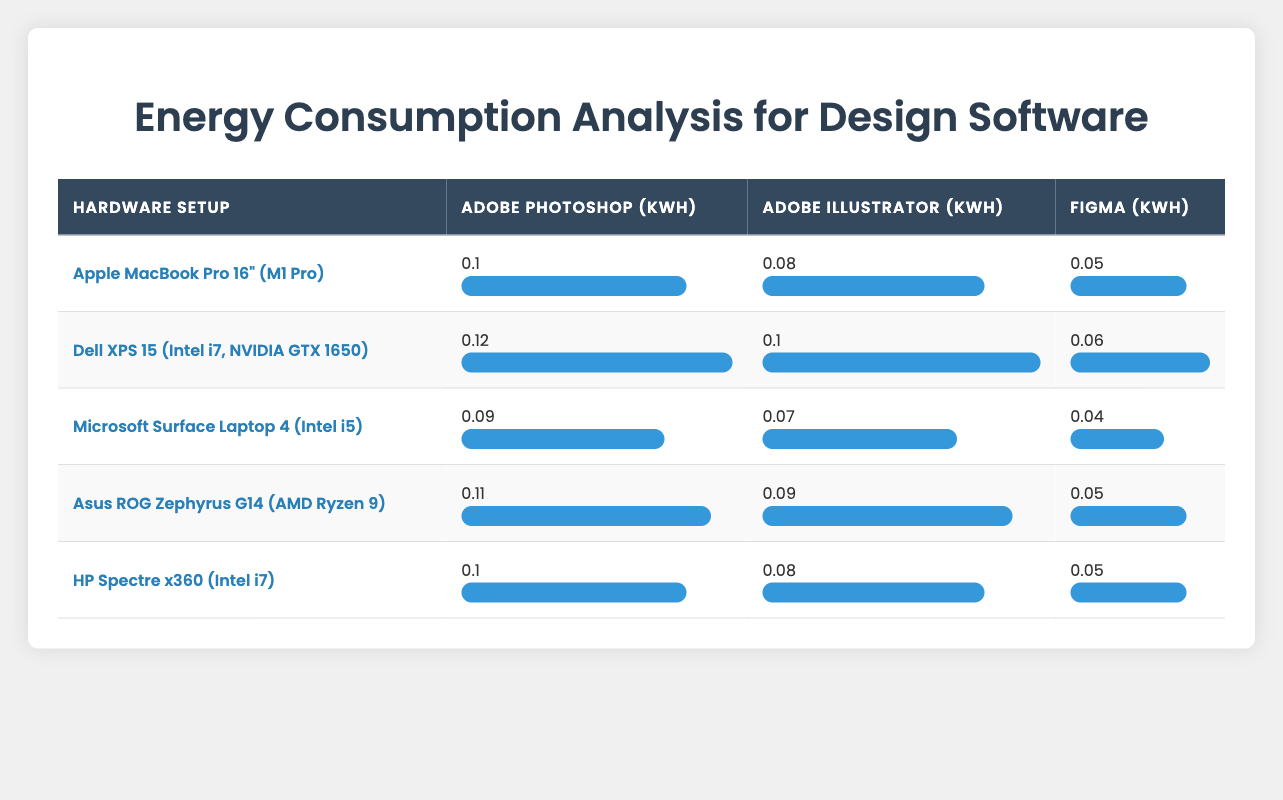What's the energy consumption of Adobe Illustrator on the Apple MacBook Pro 16"? The energy consumption for Adobe Illustrator on the Apple MacBook Pro 16" is listed as 0.08 kWh in the table.
Answer: 0.08 kWh Which hardware setup consumes the most energy running Adobe Photoshop? The table shows that the Dell XPS 15 consumes 0.12 kWh running Adobe Photoshop, which is the highest value among all setups for that software.
Answer: Dell XPS 15 What is the average energy consumption for Figma across all hardware setups? To find the average for Figma: (0.05 + 0.06 + 0.04 + 0.05 + 0.05) / 5 = 0.05 kWh. Therefore, the average Figma consumption is 0.05 kWh.
Answer: 0.05 kWh Is the energy consumption of Adobe Illustrator on the Microsoft Surface Laptop 4 greater than that on the Asus ROG Zephyrus G14? The values are 0.07 kWh for Microsoft Surface Laptop 4 and 0.09 kWh for Asus ROG Zephyrus G14. Since 0.07 is less than 0.09, the statement is false.
Answer: No How much more energy does the Dell XPS 15 consume for Adobe Photoshop compared to the Apple MacBook Pro 16"? The difference in energy consumption is 0.12 kWh (Dell XPS 15) - 0.1 kWh (Apple MacBook Pro) = 0.02 kWh. So, it consumes 0.02 kWh more.
Answer: 0.02 kWh Which setup has the least energy consumption for Adobe Illustrator, and what is that value? The lowest value for Adobe Illustrator is 0.07 kWh from the Microsoft Surface Laptop 4. This is the least value compared to others.
Answer: Microsoft Surface Laptop 4, 0.07 kWh Can you list all the setups that consume more than 0.1 kWh running Adobe Photoshop? The setups consuming more than 0.1 kWh for Adobe Photoshop are Dell XPS 15 (0.12 kWh) and Asus ROG Zephyrus G14 (0.11 kWh).
Answer: Dell XPS 15, Asus ROG Zephyrus G14 What is the total energy consumption for all setups running Figma? Adding up the energy consumption for Figma gives: 0.05 + 0.06 + 0.04 + 0.05 + 0.05 = 0.25 kWh. Therefore, the total energy consumption for Figma is 0.25 kWh.
Answer: 0.25 kWh Which hardware setup has the same energy consumption for Figma as the Apple MacBook Pro 16"? Both the Apple MacBook Pro 16" and the HP Spectre x360 have the same energy consumption for Figma at 0.05 kWh.
Answer: HP Spectre x360 